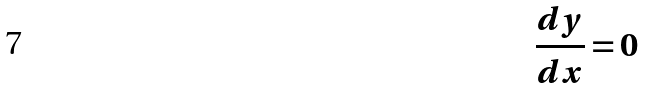<formula> <loc_0><loc_0><loc_500><loc_500>\frac { d y } { d x } = 0</formula> 